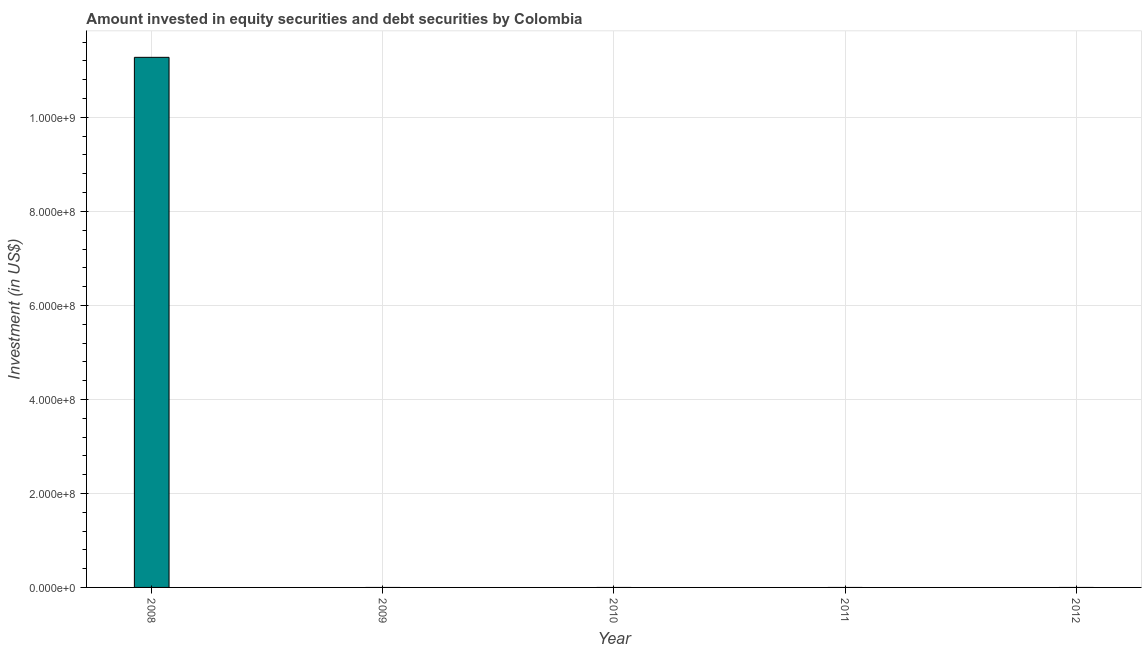Does the graph contain any zero values?
Your answer should be very brief. Yes. What is the title of the graph?
Offer a very short reply. Amount invested in equity securities and debt securities by Colombia. What is the label or title of the X-axis?
Offer a very short reply. Year. What is the label or title of the Y-axis?
Give a very brief answer. Investment (in US$). What is the portfolio investment in 2011?
Offer a terse response. 0. Across all years, what is the maximum portfolio investment?
Your answer should be compact. 1.13e+09. Across all years, what is the minimum portfolio investment?
Provide a short and direct response. 0. What is the sum of the portfolio investment?
Give a very brief answer. 1.13e+09. What is the average portfolio investment per year?
Your answer should be compact. 2.26e+08. What is the median portfolio investment?
Ensure brevity in your answer.  0. In how many years, is the portfolio investment greater than 520000000 US$?
Give a very brief answer. 1. What is the difference between the highest and the lowest portfolio investment?
Your answer should be very brief. 1.13e+09. In how many years, is the portfolio investment greater than the average portfolio investment taken over all years?
Keep it short and to the point. 1. Are all the bars in the graph horizontal?
Your answer should be compact. No. Are the values on the major ticks of Y-axis written in scientific E-notation?
Keep it short and to the point. Yes. What is the Investment (in US$) of 2008?
Provide a succinct answer. 1.13e+09. What is the Investment (in US$) of 2009?
Make the answer very short. 0. What is the Investment (in US$) of 2011?
Provide a succinct answer. 0. 